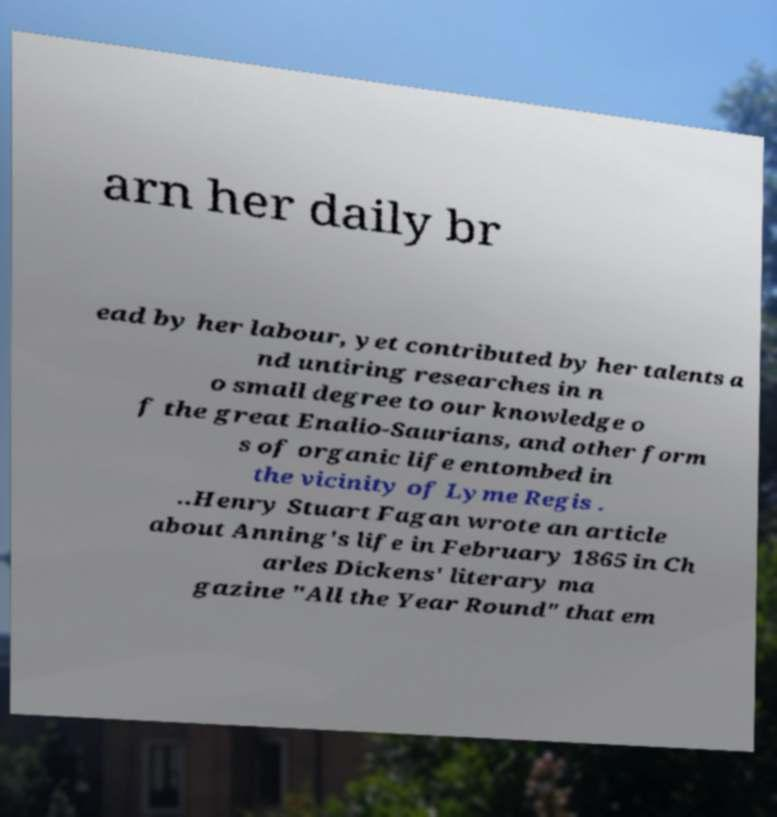Could you extract and type out the text from this image? arn her daily br ead by her labour, yet contributed by her talents a nd untiring researches in n o small degree to our knowledge o f the great Enalio-Saurians, and other form s of organic life entombed in the vicinity of Lyme Regis . ..Henry Stuart Fagan wrote an article about Anning's life in February 1865 in Ch arles Dickens' literary ma gazine "All the Year Round" that em 